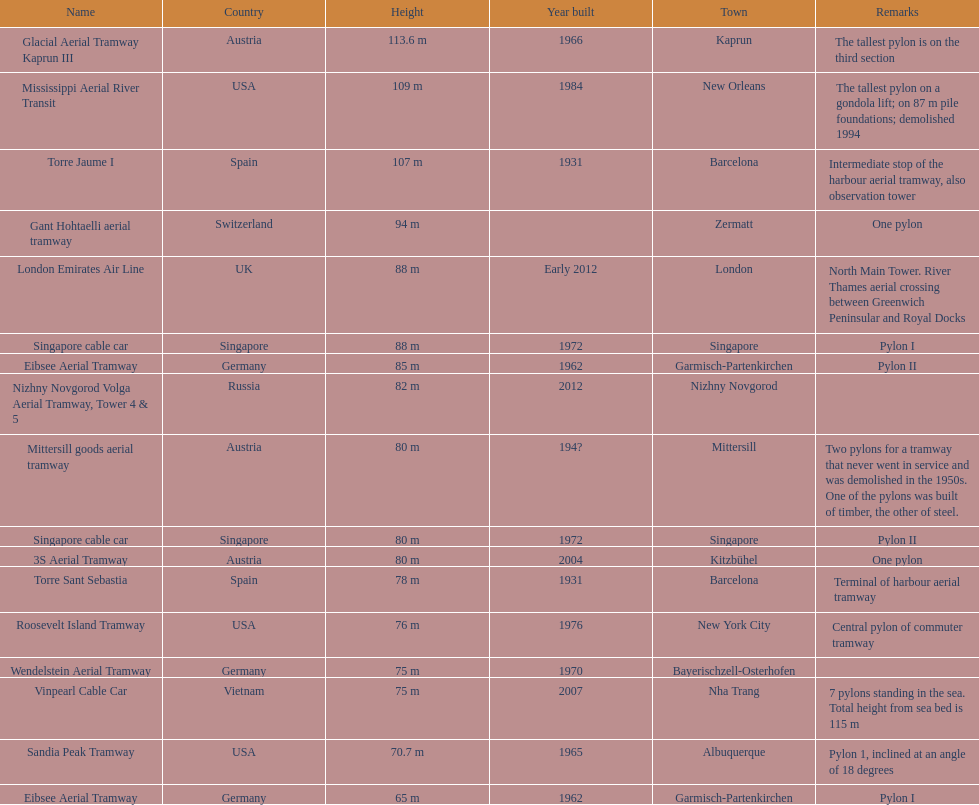How many metres is the mississippi aerial river transit from bottom to top? 109 m. 